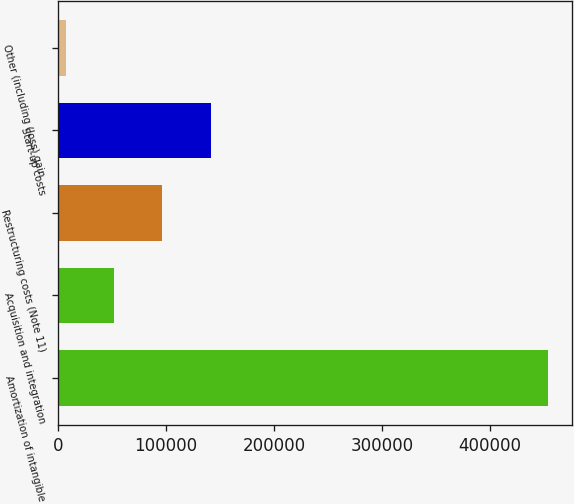Convert chart. <chart><loc_0><loc_0><loc_500><loc_500><bar_chart><fcel>Amortization of intangible<fcel>Acquisition and integration<fcel>Restructuring costs (Note 11)<fcel>Start-up costs<fcel>Other (including (loss) gain<nl><fcel>453515<fcel>52068.2<fcel>96673.4<fcel>141279<fcel>7463<nl></chart> 